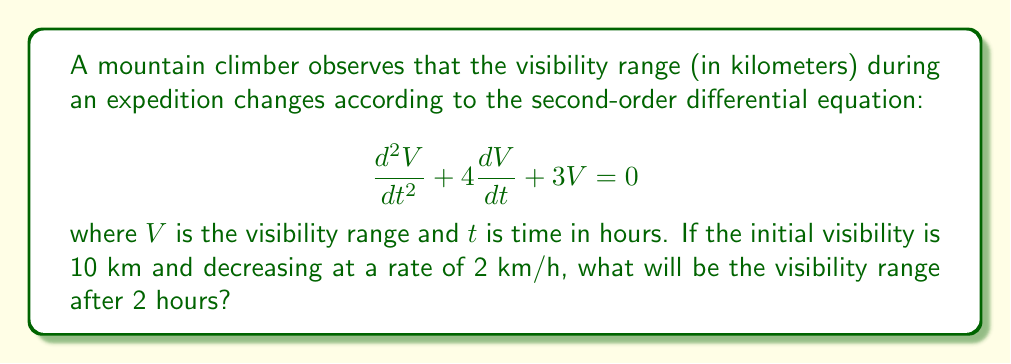Could you help me with this problem? To solve this problem, we need to follow these steps:

1) First, we need to find the general solution of the given differential equation. The characteristic equation is:

   $$r^2 + 4r + 3 = 0$$

2) Solving this quadratic equation:
   $$(r + 1)(r + 3) = 0$$
   $$r = -1 \text{ or } r = -3$$

3) Therefore, the general solution is:

   $$V(t) = C_1e^{-t} + C_2e^{-3t}$$

4) Now, we use the initial conditions to find $C_1$ and $C_2$:

   At $t = 0$, $V(0) = 10$ and $V'(0) = -2$

5) From $V(0) = 10$:
   $$10 = C_1 + C_2$$

6) From $V'(t) = -C_1e^{-t} - 3C_2e^{-3t}$, we get:
   $$-2 = -C_1 - 3C_2$$

7) Solving these equations:
   $$C_1 = 14 \text{ and } C_2 = -4$$

8) Therefore, the particular solution is:

   $$V(t) = 14e^{-t} - 4e^{-3t}$$

9) To find the visibility after 2 hours, we calculate $V(2)$:

   $$V(2) = 14e^{-2} - 4e^{-6}$$

10) Evaluating this:
    $$V(2) \approx 1.89 \text{ km}$$
Answer: The visibility range after 2 hours will be approximately 1.89 km. 